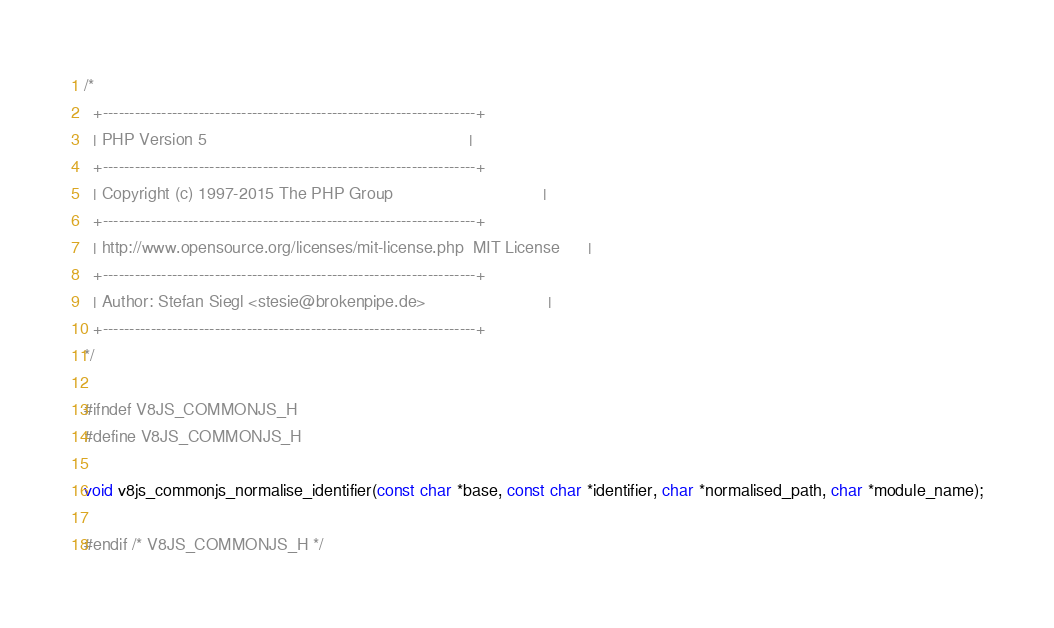Convert code to text. <code><loc_0><loc_0><loc_500><loc_500><_C_>/*
  +----------------------------------------------------------------------+
  | PHP Version 5                                                        |
  +----------------------------------------------------------------------+
  | Copyright (c) 1997-2015 The PHP Group                                |
  +----------------------------------------------------------------------+
  | http://www.opensource.org/licenses/mit-license.php  MIT License      |
  +----------------------------------------------------------------------+
  | Author: Stefan Siegl <stesie@brokenpipe.de>                          |
  +----------------------------------------------------------------------+
*/

#ifndef V8JS_COMMONJS_H
#define V8JS_COMMONJS_H

void v8js_commonjs_normalise_identifier(const char *base, const char *identifier, char *normalised_path, char *module_name);

#endif /* V8JS_COMMONJS_H */
</code> 